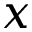<formula> <loc_0><loc_0><loc_500><loc_500>x</formula> 